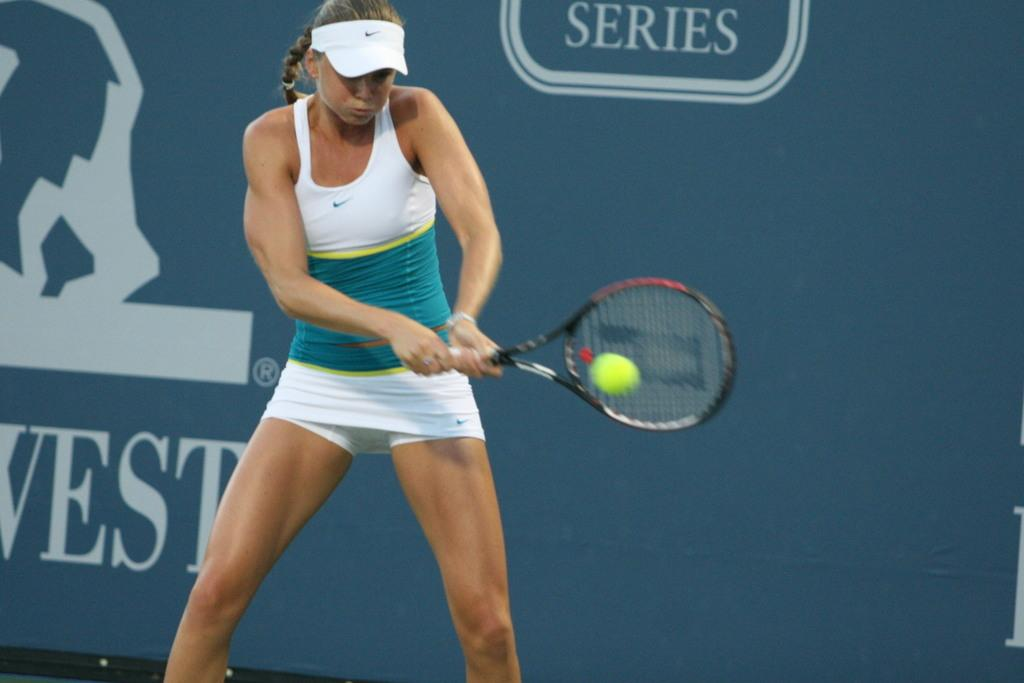Who is present in the image? There is a woman in the image. What is the woman doing in the image? The woman is standing and holding a bat. What can be seen in the background of the image? There is a gray-colored wall in the background. What is written on the wall in the image? The word "series" is written on the wall. How many feet are visible in the image? There is no mention of feet in the image, as the focus is on the woman holding a bat and the wall with the word "series" written on it. 